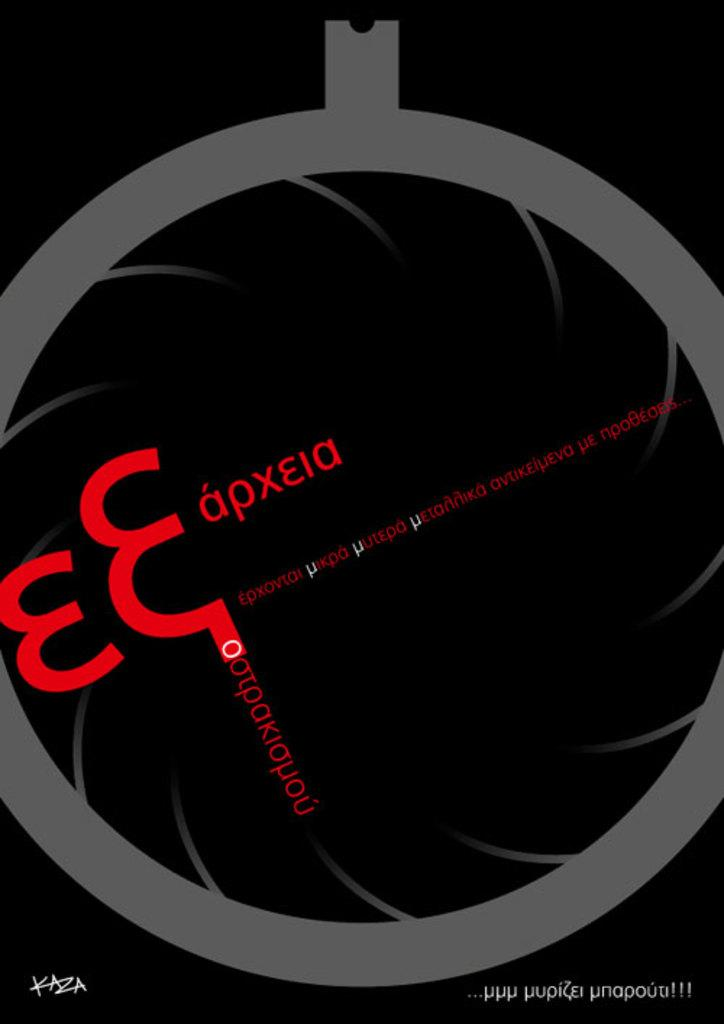<image>
Write a terse but informative summary of the picture. An advertisement by KAZA features black and gray artwork with red lettering. 